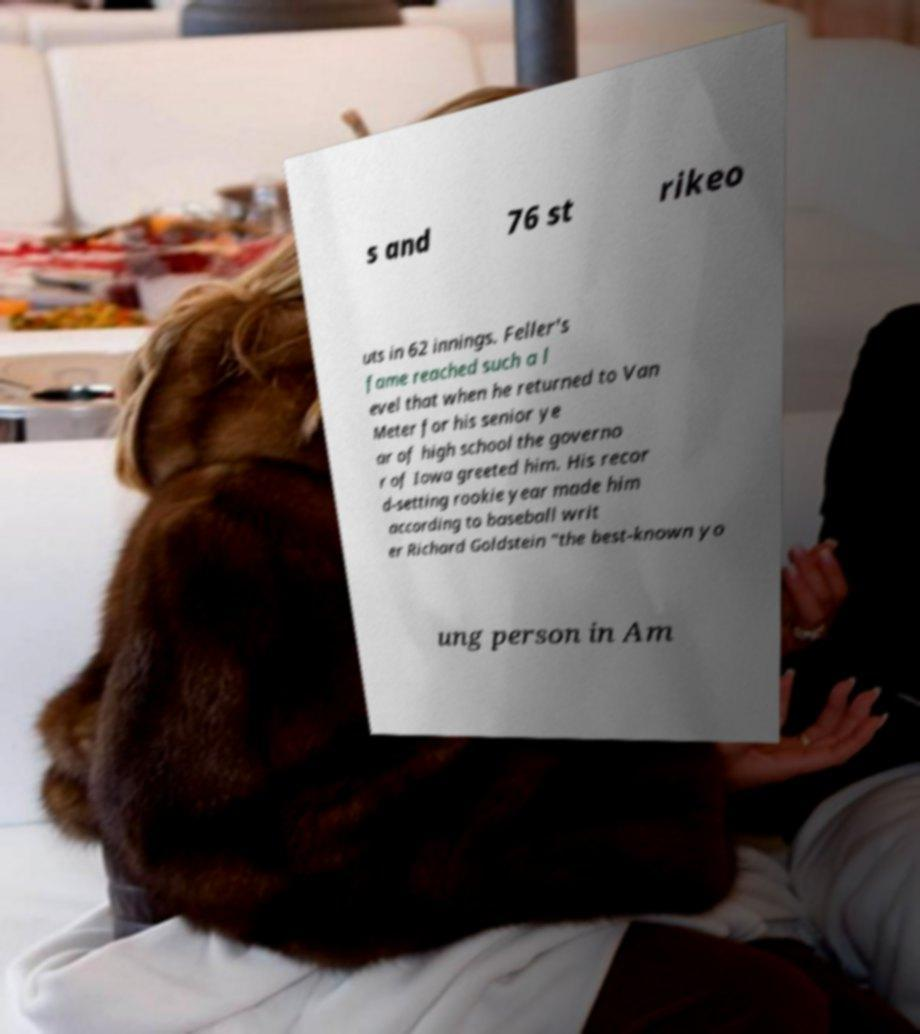I need the written content from this picture converted into text. Can you do that? s and 76 st rikeo uts in 62 innings. Feller's fame reached such a l evel that when he returned to Van Meter for his senior ye ar of high school the governo r of Iowa greeted him. His recor d-setting rookie year made him according to baseball writ er Richard Goldstein "the best-known yo ung person in Am 